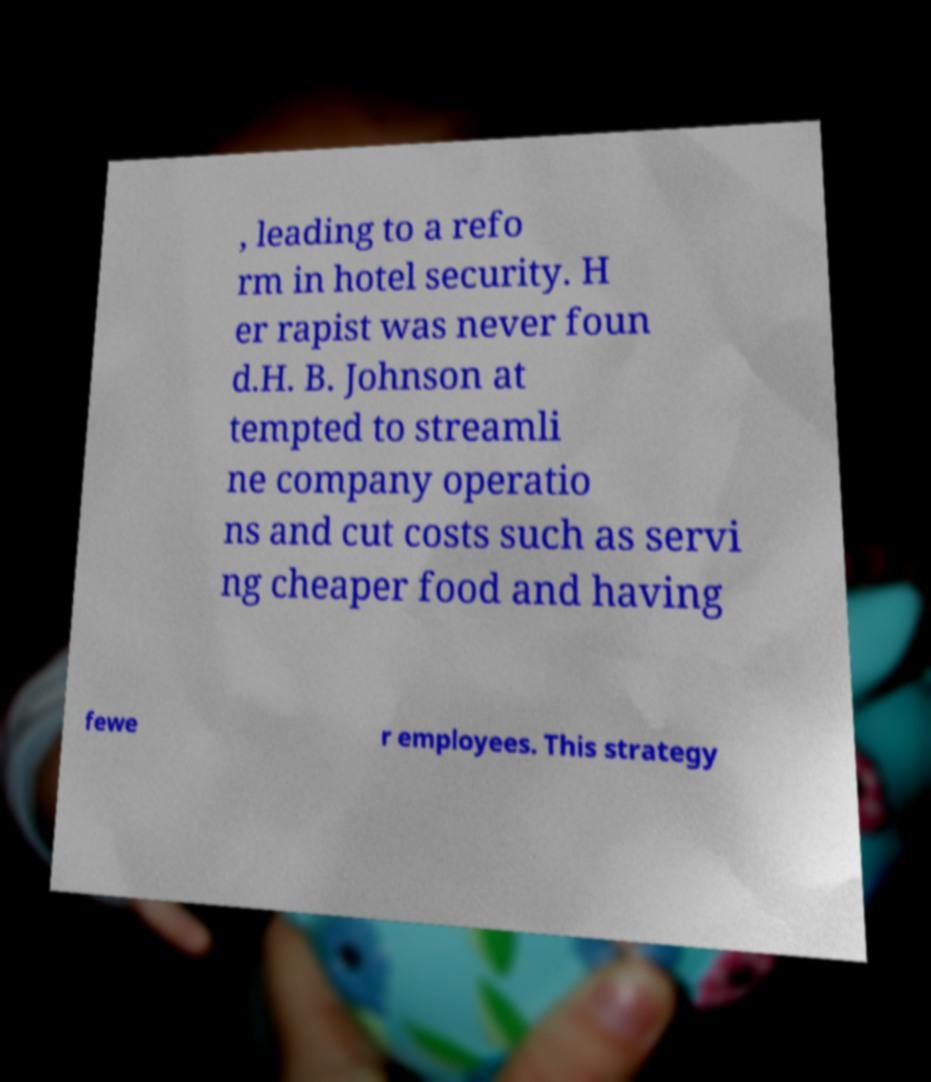I need the written content from this picture converted into text. Can you do that? , leading to a refo rm in hotel security. H er rapist was never foun d.H. B. Johnson at tempted to streamli ne company operatio ns and cut costs such as servi ng cheaper food and having fewe r employees. This strategy 